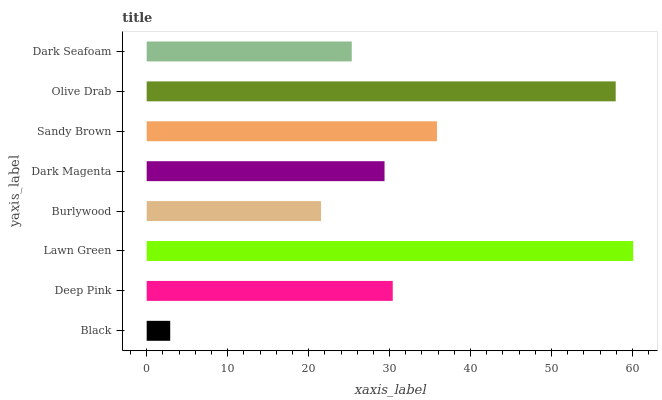Is Black the minimum?
Answer yes or no. Yes. Is Lawn Green the maximum?
Answer yes or no. Yes. Is Deep Pink the minimum?
Answer yes or no. No. Is Deep Pink the maximum?
Answer yes or no. No. Is Deep Pink greater than Black?
Answer yes or no. Yes. Is Black less than Deep Pink?
Answer yes or no. Yes. Is Black greater than Deep Pink?
Answer yes or no. No. Is Deep Pink less than Black?
Answer yes or no. No. Is Deep Pink the high median?
Answer yes or no. Yes. Is Dark Magenta the low median?
Answer yes or no. Yes. Is Sandy Brown the high median?
Answer yes or no. No. Is Black the low median?
Answer yes or no. No. 